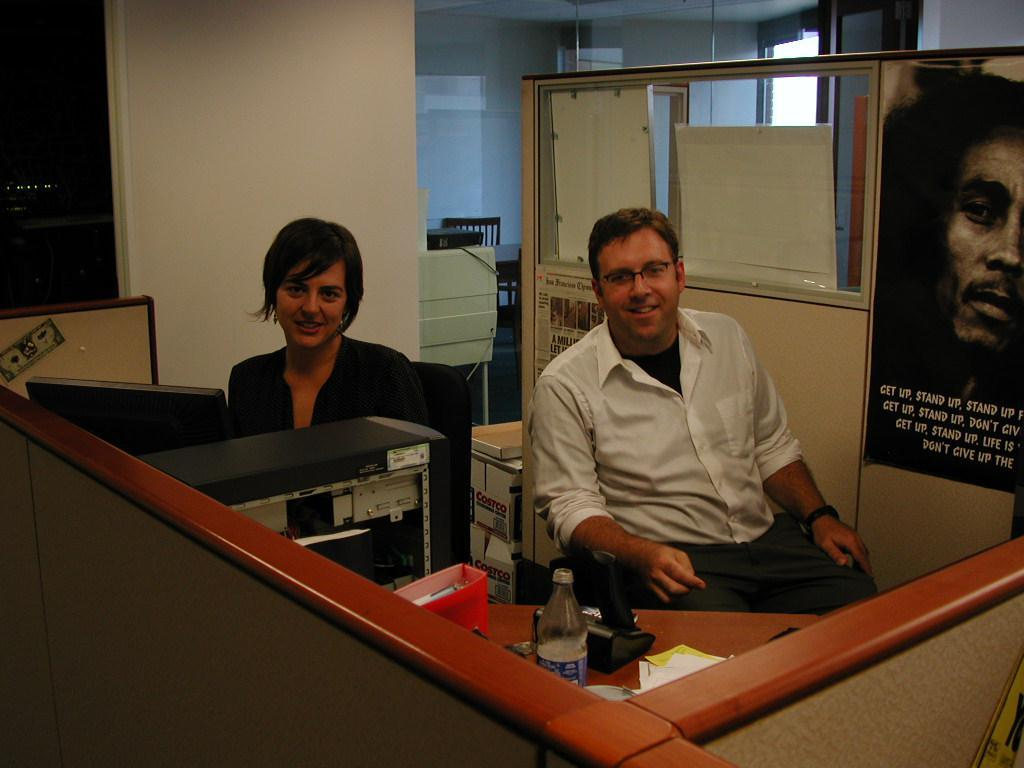How many people are in the image? There are two people in the image. Can you describe the positions of the people in the image? The man is on the right side of the image, and the woman is on the left side of the image. What does the image depict? The image depicts a system. What can be seen on the desk in the image? There is a water bottle on a desk in the image. What type of dress is the woman wearing in the image? There is no dress mentioned or visible in the image; the woman is on the left side of the image, but no clothing details are provided. 